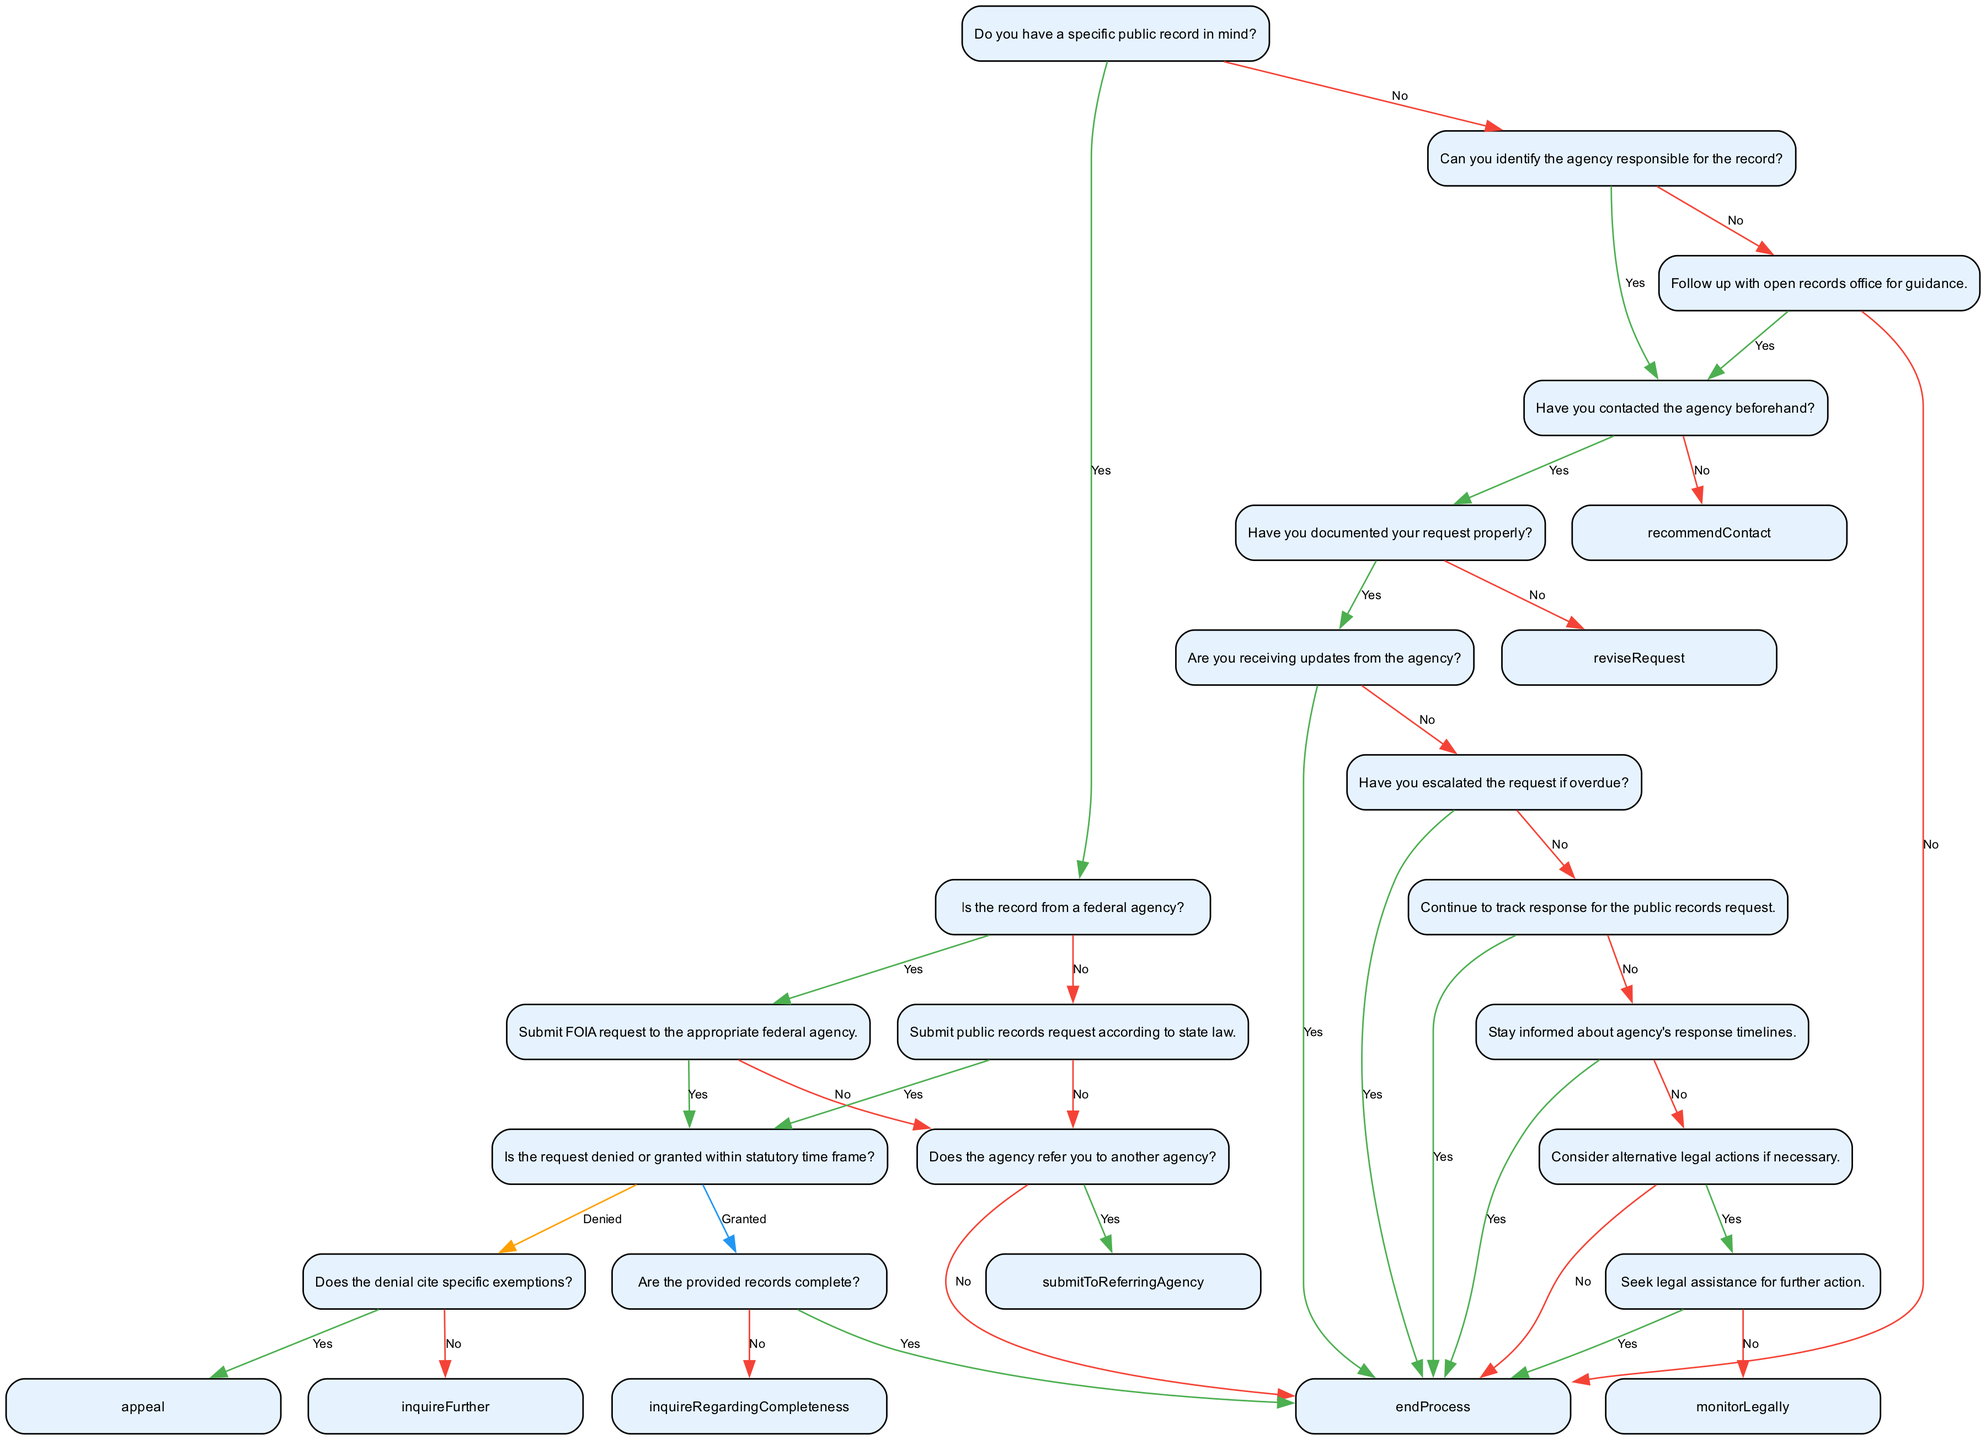What is the first question in the decision tree? The first node in the decision tree asks whether the individual has a specific public record in mind. This serves as the starting point for navigating the subsequent steps.
Answer: Do you have a specific public record in mind? How many nodes are in the decision tree? To count the nodes, we examine the provided data. Each node represents a decision point or a step in the process, totaling 14 identified nodes in the decision tree.
Answer: 14 What action should you take if the record is from a federal agency? If the record is identified as being from a federal agency, the next step is to submit a FOIA request to the appropriate federal agency, as indicated in the tree.
Answer: Submit FOIA request to the appropriate federal agency What happens if your request is denied? If a request is denied, the next step in the tree involves determining whether the denial cites specific exemptions. This leads to either an appeal process or a further inquiry.
Answer: Does the denial cite specific exemptions? If you haven't documented your request properly, what should you do next? According to the decision tree, if the request has not been documented properly, the next step is to revise the request before proceeding further to ensure it's correctly submitted.
Answer: Revise request What should you do if you're not receiving updates from the agency? If updates are not being received from the agency regarding the status of the request, the next step is to follow up to encourage communication and updates on the request's progress.
Answer: Follow up What is the outcome if the provided records are incomplete? If the received records are found to be incomplete, you should inquire further regarding the completeness of the records to seek out any missing information or pieces.
Answer: Inquire regarding completeness If your request is overdue, what action should you take? If the request is overdue, the decision tree recommends escalating the request to encourage quicker processing or follow-up by the agency, which is essential for keeping track of the request.
Answer: End process What does "stay engaged" refer to in the context of monitoring a request? "Stay engaged" refers to the necessity to remain informed about the agency's response timelines to maintain awareness of when to expect feedback or results regarding the public records request.
Answer: Stay informed about agency's response timelines 